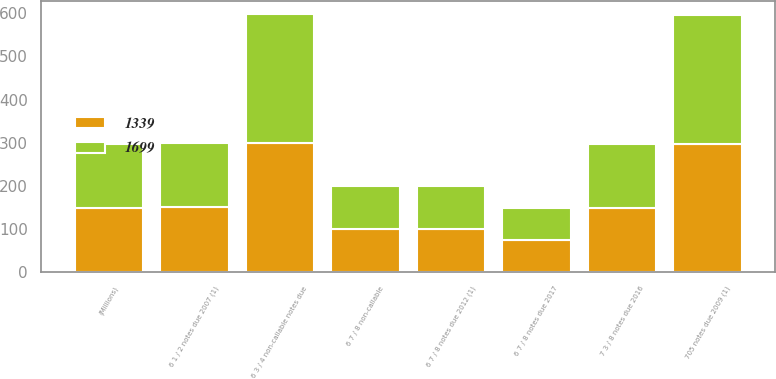<chart> <loc_0><loc_0><loc_500><loc_500><stacked_bar_chart><ecel><fcel>(Millions)<fcel>6 3 / 4 non-callable notes due<fcel>6 7 / 8 non-callable<fcel>6 1 / 2 notes due 2007 (1)<fcel>705 notes due 2009 (1)<fcel>6 7 / 8 notes due 2012 (1)<fcel>7 3 / 8 notes due 2016<fcel>6 7 / 8 notes due 2017<nl><fcel>1339<fcel>149<fcel>300<fcel>100<fcel>150<fcel>298<fcel>100<fcel>149<fcel>74<nl><fcel>1699<fcel>149<fcel>299<fcel>100<fcel>150<fcel>298<fcel>100<fcel>149<fcel>74<nl></chart> 